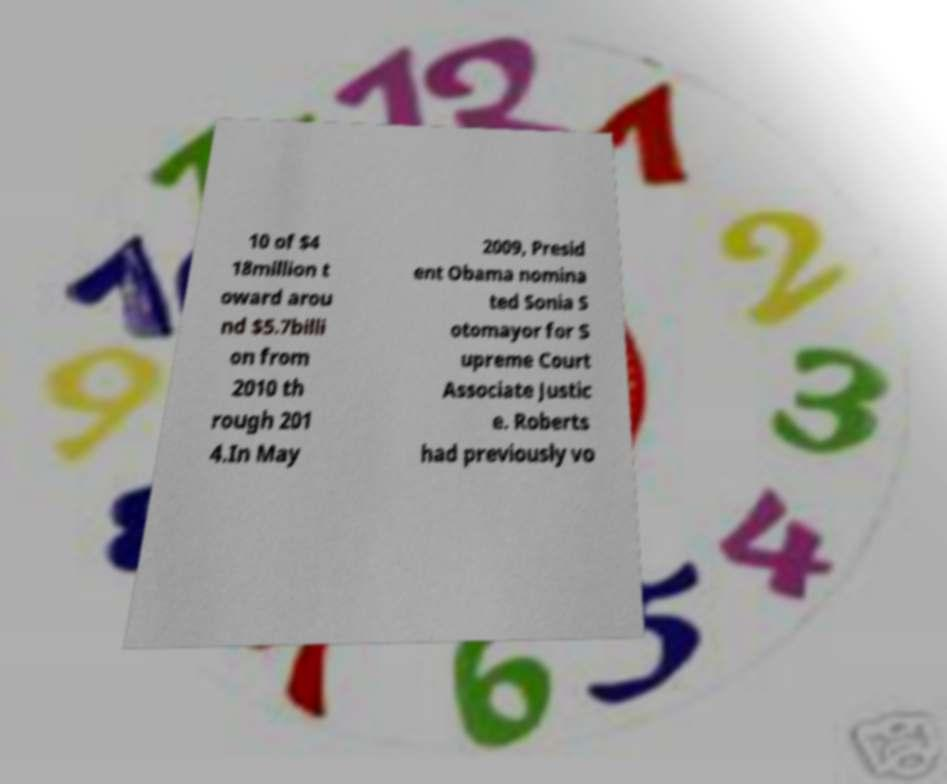What messages or text are displayed in this image? I need them in a readable, typed format. 10 of $4 18million t oward arou nd $5.7billi on from 2010 th rough 201 4.In May 2009, Presid ent Obama nomina ted Sonia S otomayor for S upreme Court Associate Justic e. Roberts had previously vo 